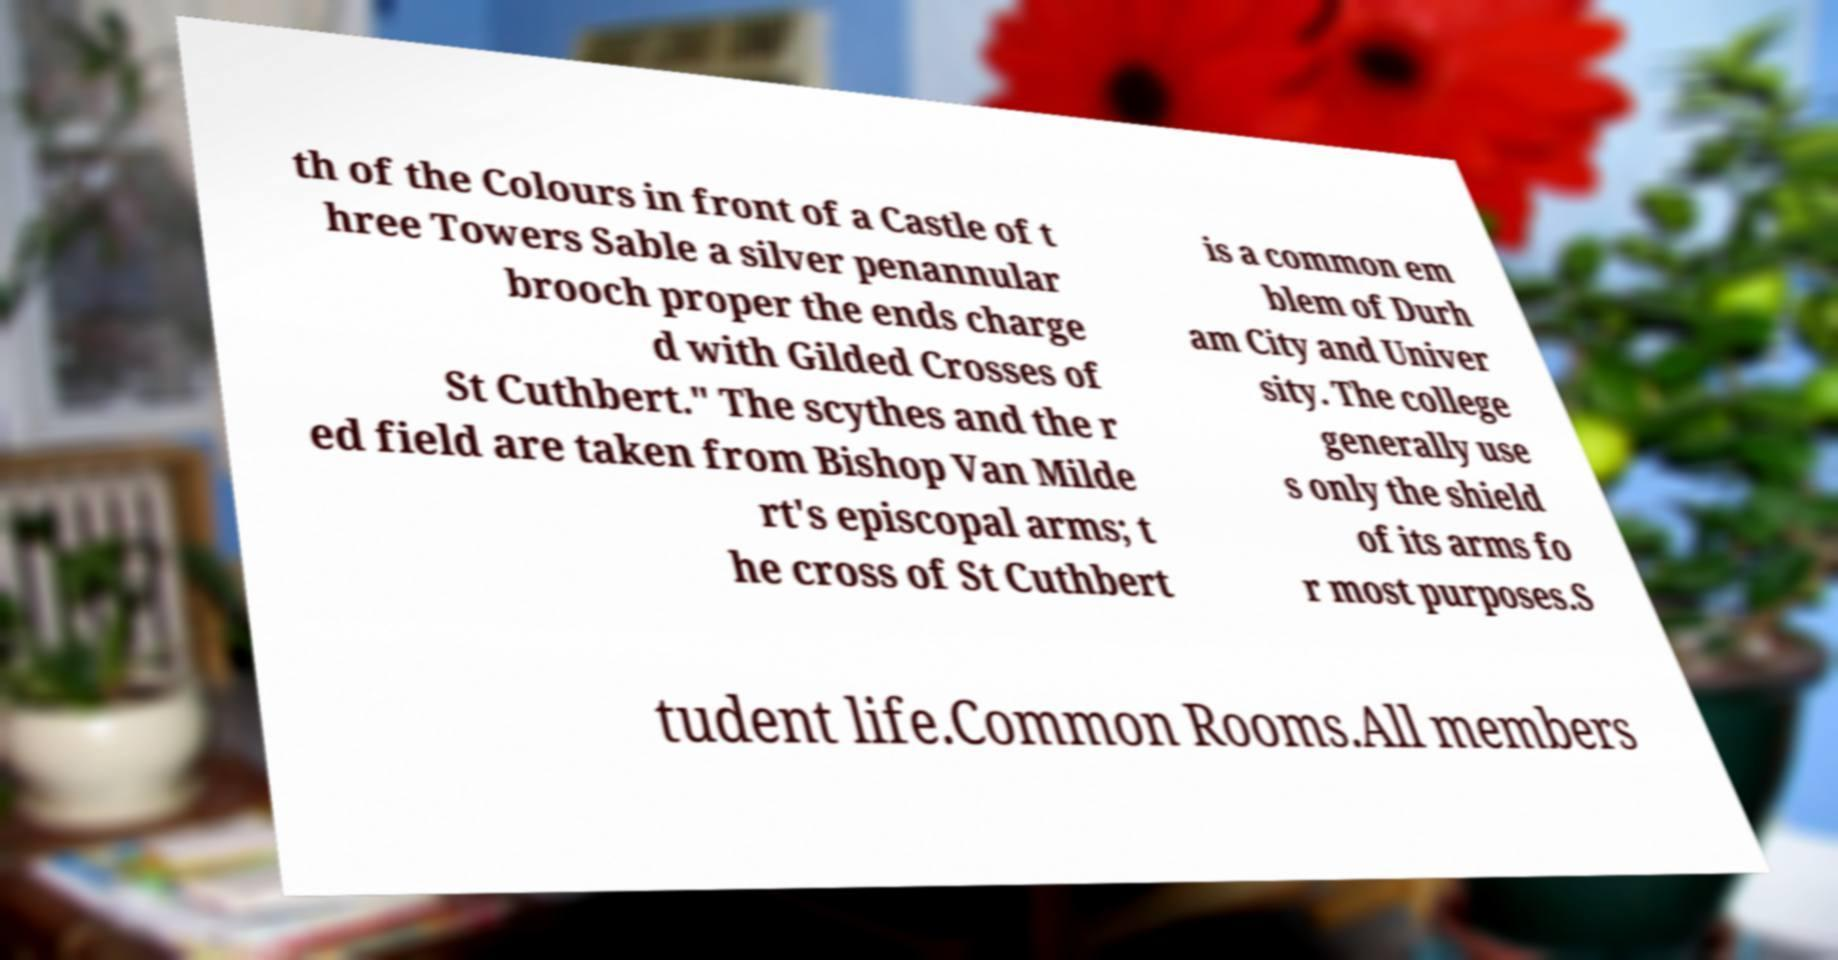Can you read and provide the text displayed in the image?This photo seems to have some interesting text. Can you extract and type it out for me? th of the Colours in front of a Castle of t hree Towers Sable a silver penannular brooch proper the ends charge d with Gilded Crosses of St Cuthbert." The scythes and the r ed field are taken from Bishop Van Milde rt's episcopal arms; t he cross of St Cuthbert is a common em blem of Durh am City and Univer sity. The college generally use s only the shield of its arms fo r most purposes.S tudent life.Common Rooms.All members 